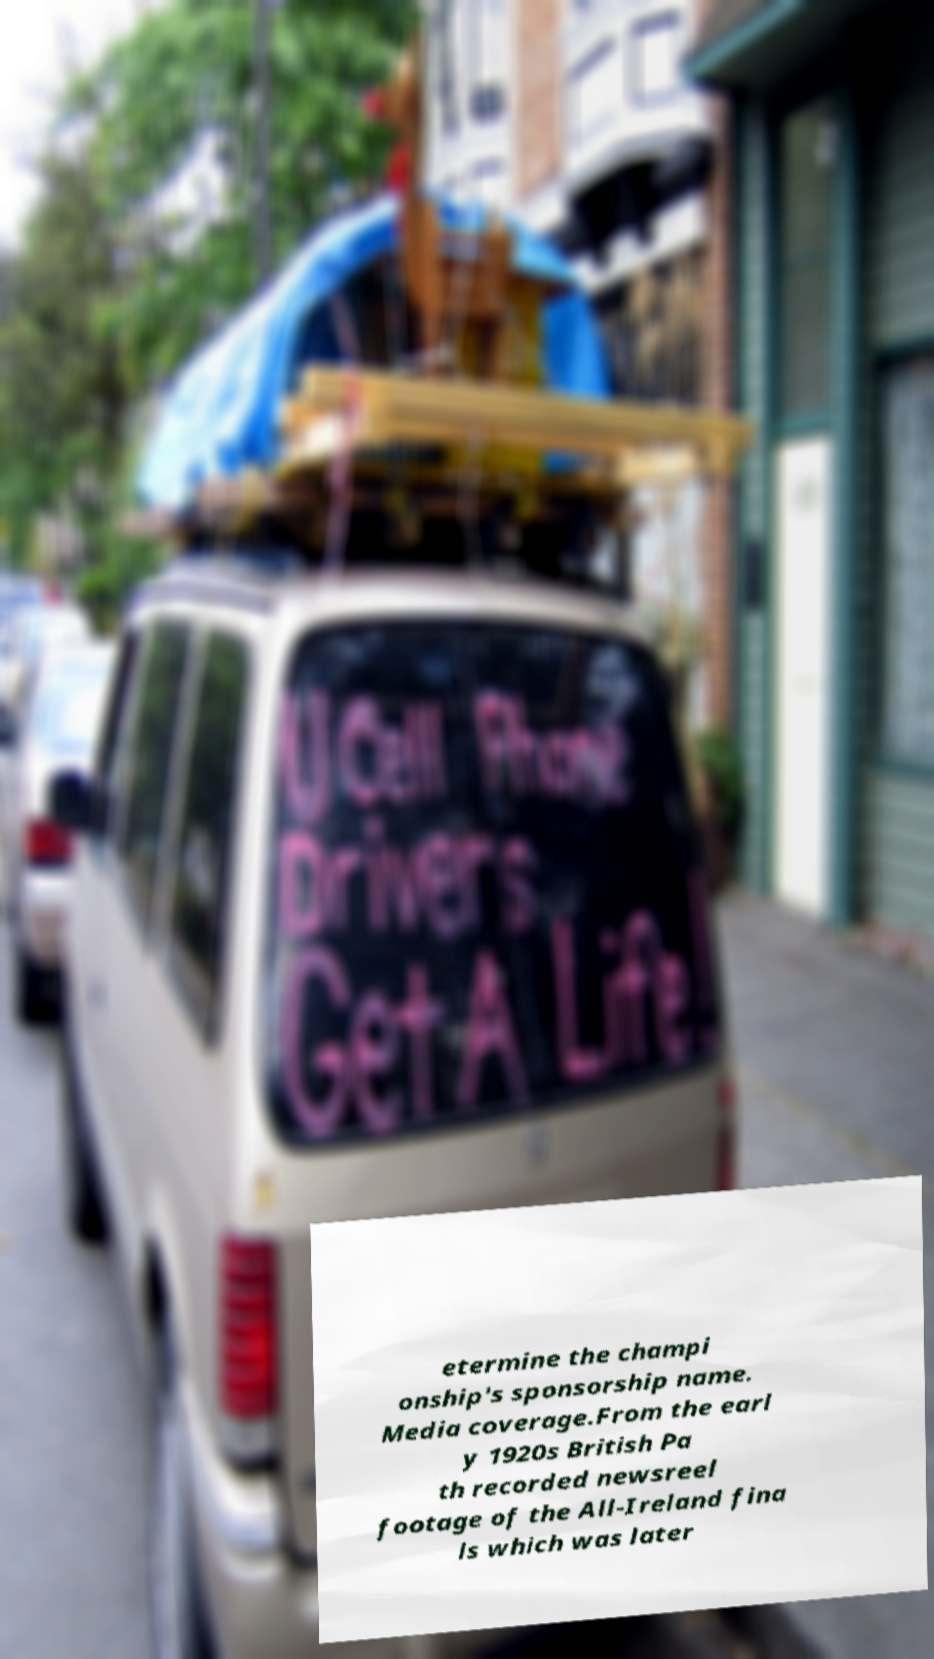I need the written content from this picture converted into text. Can you do that? etermine the champi onship's sponsorship name. Media coverage.From the earl y 1920s British Pa th recorded newsreel footage of the All-Ireland fina ls which was later 